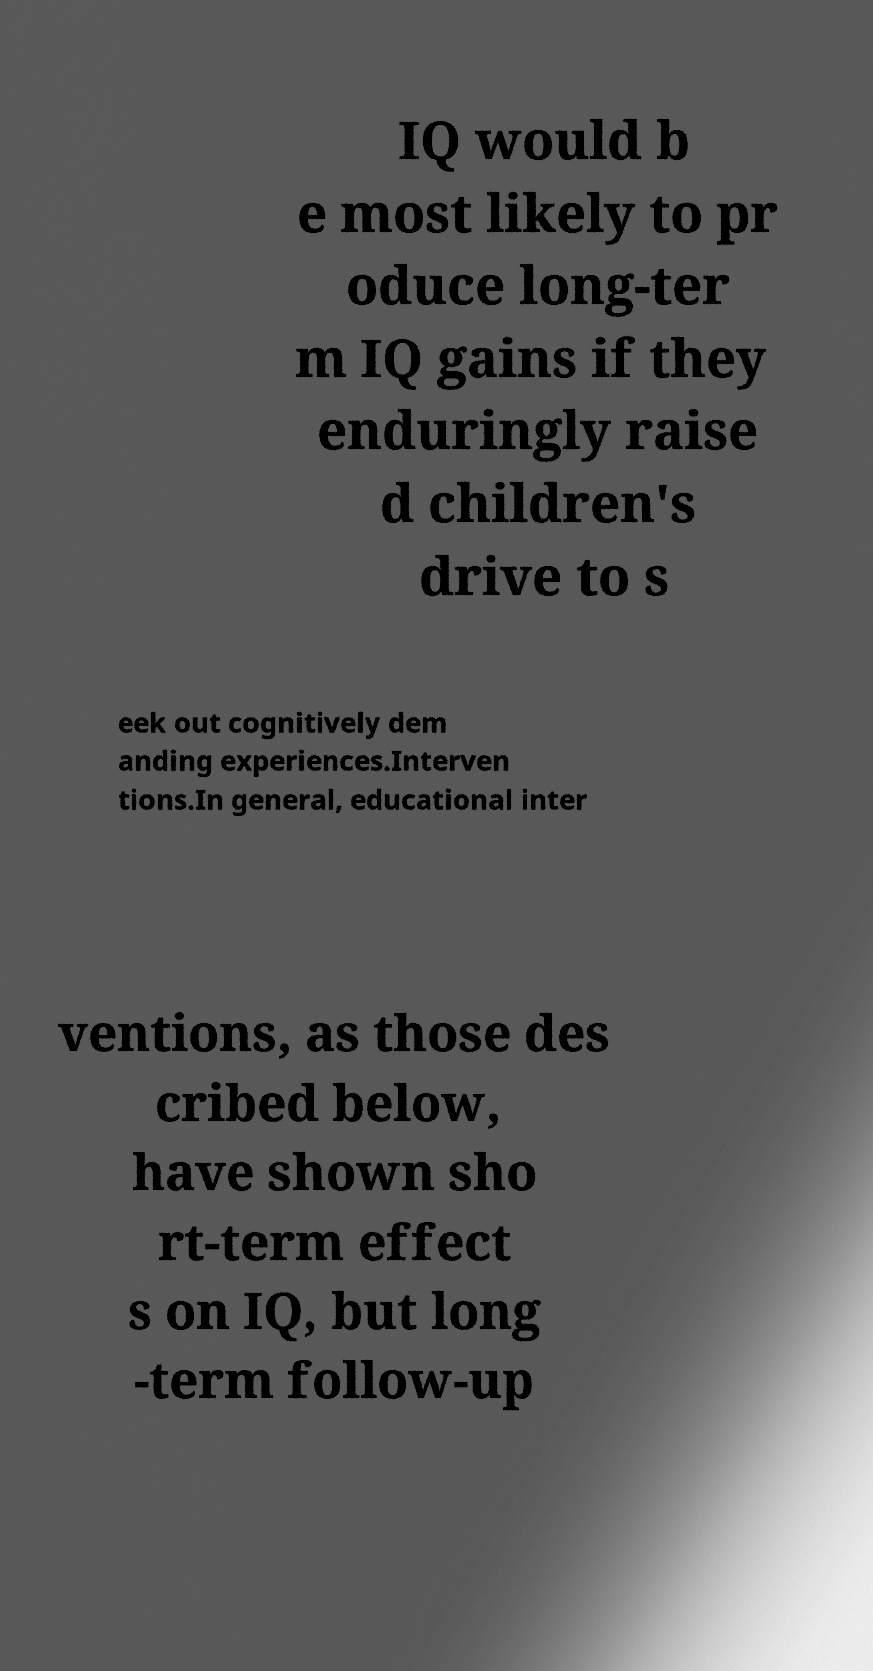For documentation purposes, I need the text within this image transcribed. Could you provide that? IQ would b e most likely to pr oduce long-ter m IQ gains if they enduringly raise d children's drive to s eek out cognitively dem anding experiences.Interven tions.In general, educational inter ventions, as those des cribed below, have shown sho rt-term effect s on IQ, but long -term follow-up 